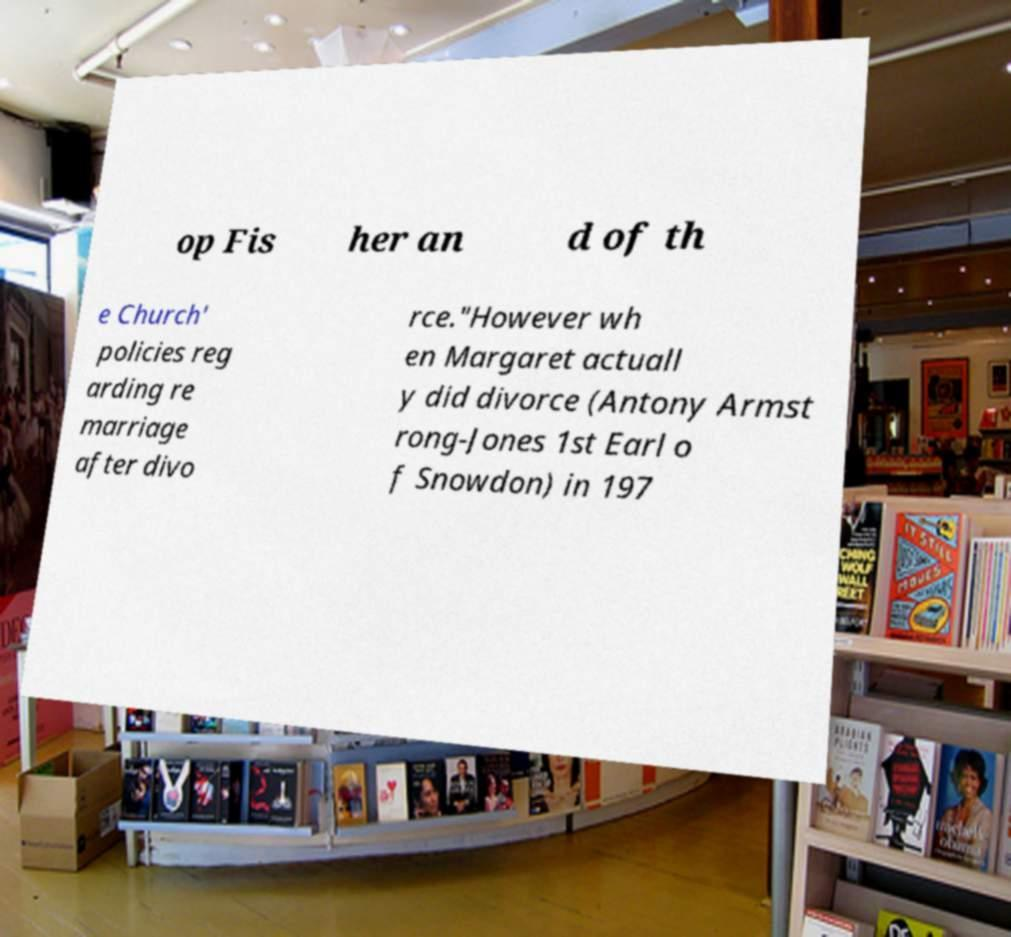I need the written content from this picture converted into text. Can you do that? op Fis her an d of th e Church' policies reg arding re marriage after divo rce."However wh en Margaret actuall y did divorce (Antony Armst rong-Jones 1st Earl o f Snowdon) in 197 